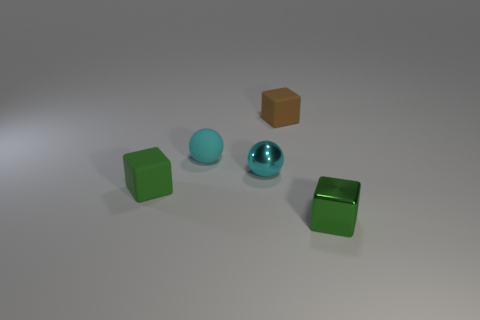Do the small brown block and the small block to the right of the brown matte cube have the same material?
Provide a succinct answer. No. There is a metal sphere that is the same size as the cyan rubber ball; what is its color?
Your answer should be compact. Cyan. There is a shiny ball on the left side of the tiny shiny object to the right of the brown rubber thing; how big is it?
Ensure brevity in your answer.  Small. Is the color of the small rubber sphere the same as the metal thing that is on the left side of the small green metal cube?
Keep it short and to the point. Yes. Are there fewer cyan matte spheres that are on the right side of the tiny cyan shiny object than blue cylinders?
Keep it short and to the point. No. What number of other things are the same size as the brown cube?
Provide a succinct answer. 4. Is the shape of the tiny metallic thing that is right of the cyan shiny ball the same as  the tiny cyan metallic object?
Your answer should be compact. No. Is the number of tiny metal blocks that are on the right side of the shiny block greater than the number of tiny rubber spheres?
Provide a succinct answer. No. There is a thing that is both on the left side of the brown rubber object and to the right of the small cyan rubber ball; what material is it made of?
Ensure brevity in your answer.  Metal. Is there any other thing that has the same shape as the tiny green shiny thing?
Your answer should be very brief. Yes. 